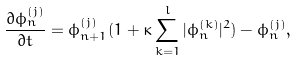Convert formula to latex. <formula><loc_0><loc_0><loc_500><loc_500>\frac { \partial \phi _ { n } ^ { ( j ) } } { \partial t } = \phi _ { n + 1 } ^ { ( j ) } ( 1 + \kappa \sum _ { k = 1 } ^ { l } | \phi _ { n } ^ { ( k ) } | ^ { 2 } ) - \phi _ { n } ^ { ( j ) } ,</formula> 